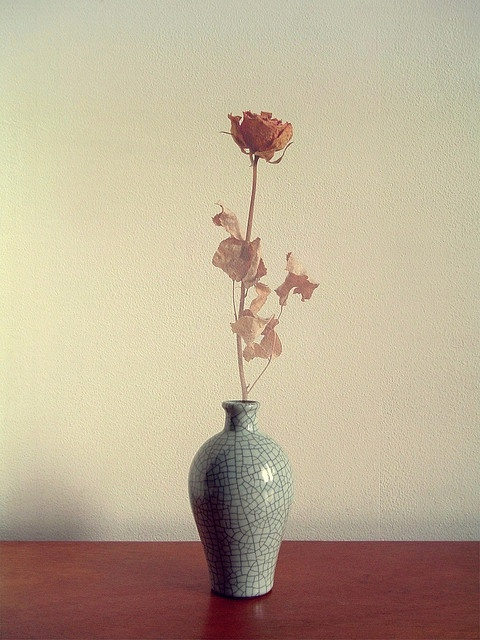Describe the objects in this image and their specific colors. I can see a vase in lightgray, gray, darkgray, black, and beige tones in this image. 